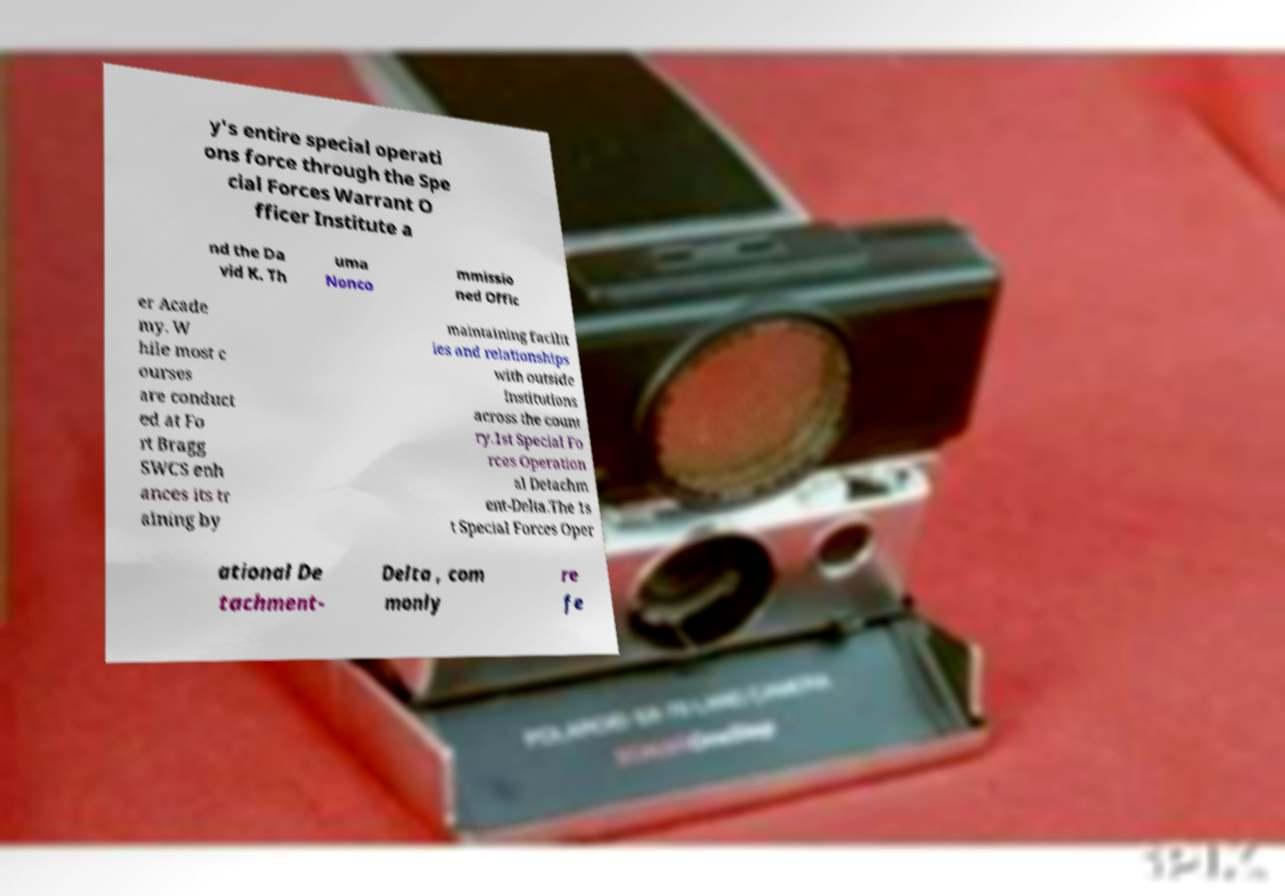I need the written content from this picture converted into text. Can you do that? y's entire special operati ons force through the Spe cial Forces Warrant O fficer Institute a nd the Da vid K. Th uma Nonco mmissio ned Offic er Acade my. W hile most c ourses are conduct ed at Fo rt Bragg SWCS enh ances its tr aining by maintaining facilit ies and relationships with outside institutions across the count ry.1st Special Fo rces Operation al Detachm ent-Delta.The 1s t Special Forces Oper ational De tachment- Delta , com monly re fe 